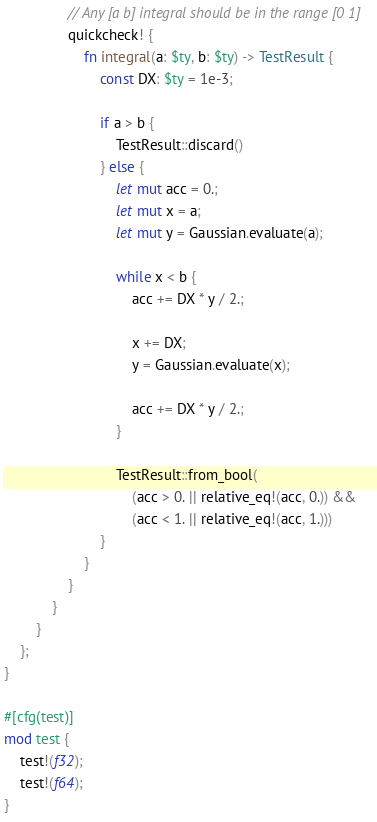Convert code to text. <code><loc_0><loc_0><loc_500><loc_500><_Rust_>
                // Any [a b] integral should be in the range [0 1]
                quickcheck! {
                    fn integral(a: $ty, b: $ty) -> TestResult {
                        const DX: $ty = 1e-3;

                        if a > b {
                            TestResult::discard()
                        } else {
                            let mut acc = 0.;
                            let mut x = a;
                            let mut y = Gaussian.evaluate(a);

                            while x < b {
                                acc += DX * y / 2.;

                                x += DX;
                                y = Gaussian.evaluate(x);

                                acc += DX * y / 2.;
                            }

                            TestResult::from_bool(
                                (acc > 0. || relative_eq!(acc, 0.)) &&
                                (acc < 1. || relative_eq!(acc, 1.)))
                        }
                    }
                }
            }
        }
    };
}

#[cfg(test)]
mod test {
    test!(f32);
    test!(f64);
}
</code> 